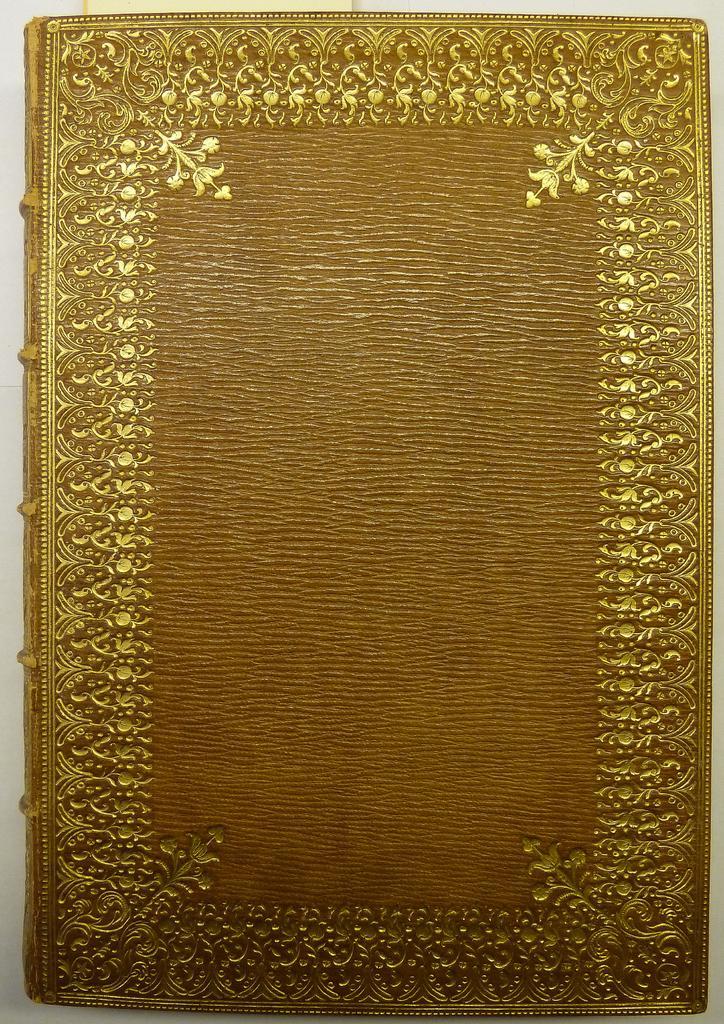In one or two sentences, can you explain what this image depicts? As we can see in the image there is orange and gold color book. 